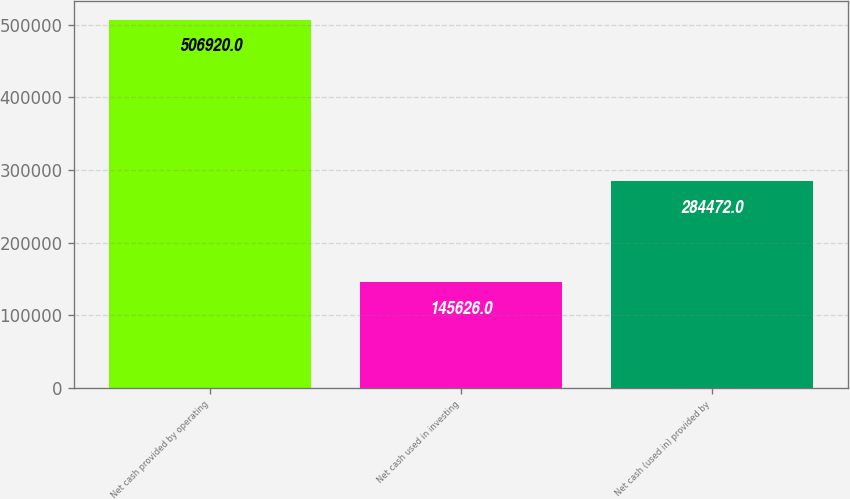<chart> <loc_0><loc_0><loc_500><loc_500><bar_chart><fcel>Net cash provided by operating<fcel>Net cash used in investing<fcel>Net cash (used in) provided by<nl><fcel>506920<fcel>145626<fcel>284472<nl></chart> 